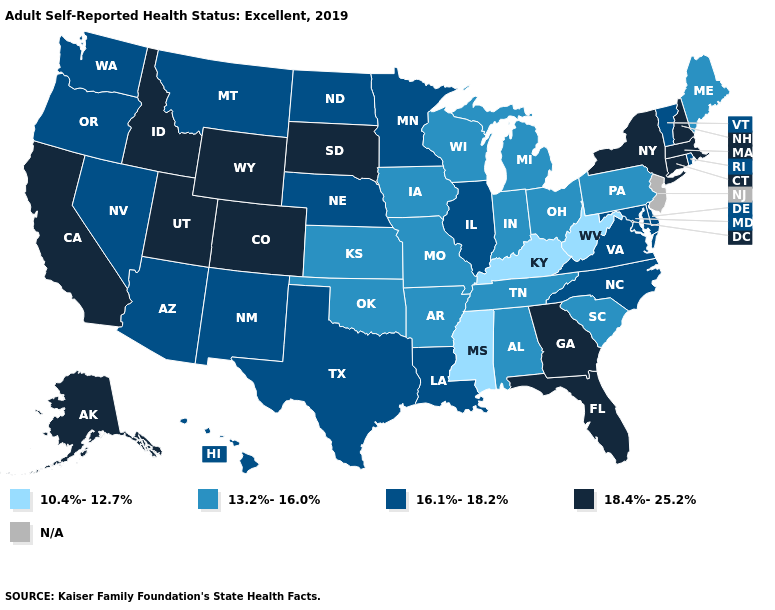Name the states that have a value in the range 18.4%-25.2%?
Concise answer only. Alaska, California, Colorado, Connecticut, Florida, Georgia, Idaho, Massachusetts, New Hampshire, New York, South Dakota, Utah, Wyoming. Name the states that have a value in the range N/A?
Concise answer only. New Jersey. Does the map have missing data?
Short answer required. Yes. What is the lowest value in the USA?
Concise answer only. 10.4%-12.7%. What is the value of Washington?
Give a very brief answer. 16.1%-18.2%. What is the highest value in the USA?
Answer briefly. 18.4%-25.2%. Name the states that have a value in the range 13.2%-16.0%?
Be succinct. Alabama, Arkansas, Indiana, Iowa, Kansas, Maine, Michigan, Missouri, Ohio, Oklahoma, Pennsylvania, South Carolina, Tennessee, Wisconsin. Does the first symbol in the legend represent the smallest category?
Give a very brief answer. Yes. What is the value of North Dakota?
Short answer required. 16.1%-18.2%. What is the lowest value in the MidWest?
Concise answer only. 13.2%-16.0%. Which states have the lowest value in the South?
Write a very short answer. Kentucky, Mississippi, West Virginia. Does New York have the highest value in the Northeast?
Keep it brief. Yes. 